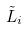Convert formula to latex. <formula><loc_0><loc_0><loc_500><loc_500>\tilde { L } _ { i }</formula> 